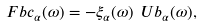Convert formula to latex. <formula><loc_0><loc_0><loc_500><loc_500>\ F b c _ { \alpha } ( \omega ) = - \xi _ { \alpha } ( \omega ) \ U b _ { \alpha } ( \omega ) , \\</formula> 